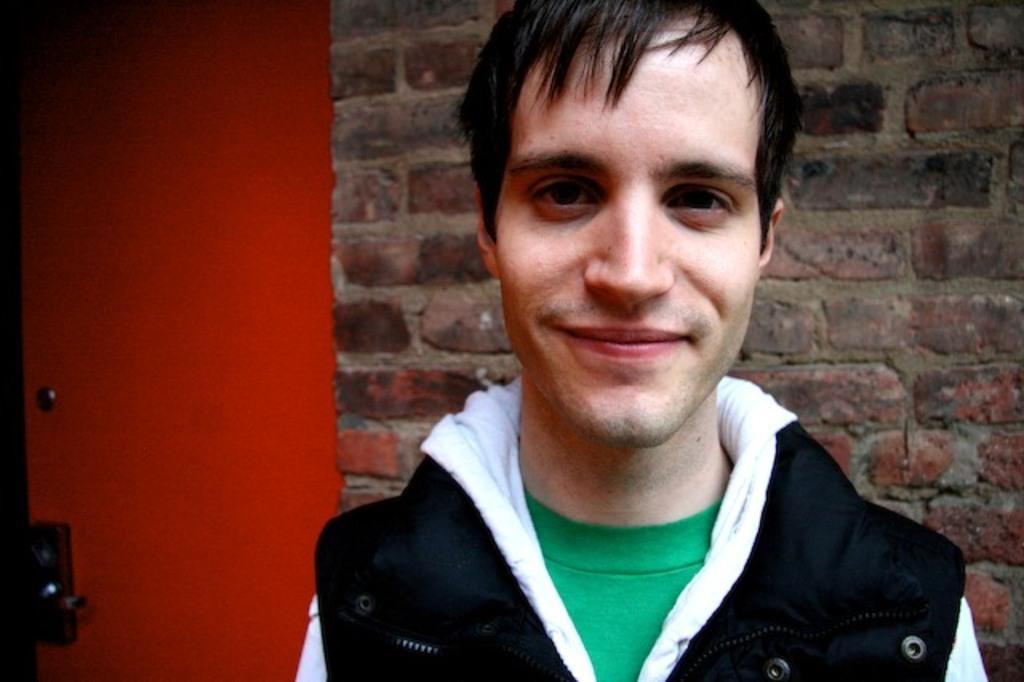In one or two sentences, can you explain what this image depicts? In the middle of the image we can see a man, he is smiling, behind to him we can see a red color door and a wall. 